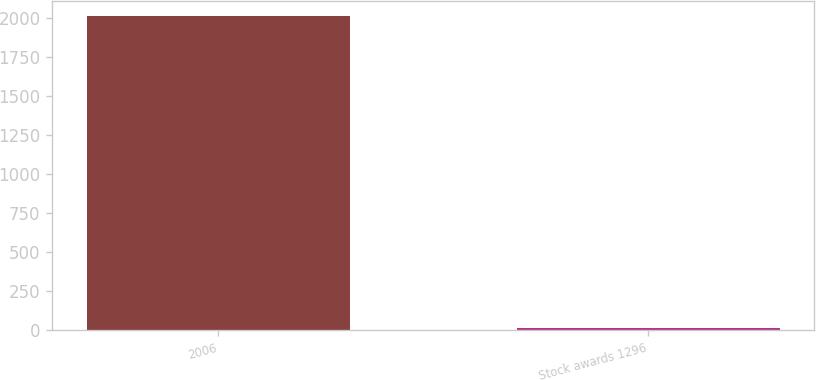<chart> <loc_0><loc_0><loc_500><loc_500><bar_chart><fcel>2006<fcel>Stock awards 1296<nl><fcel>2008<fcel>15.09<nl></chart> 